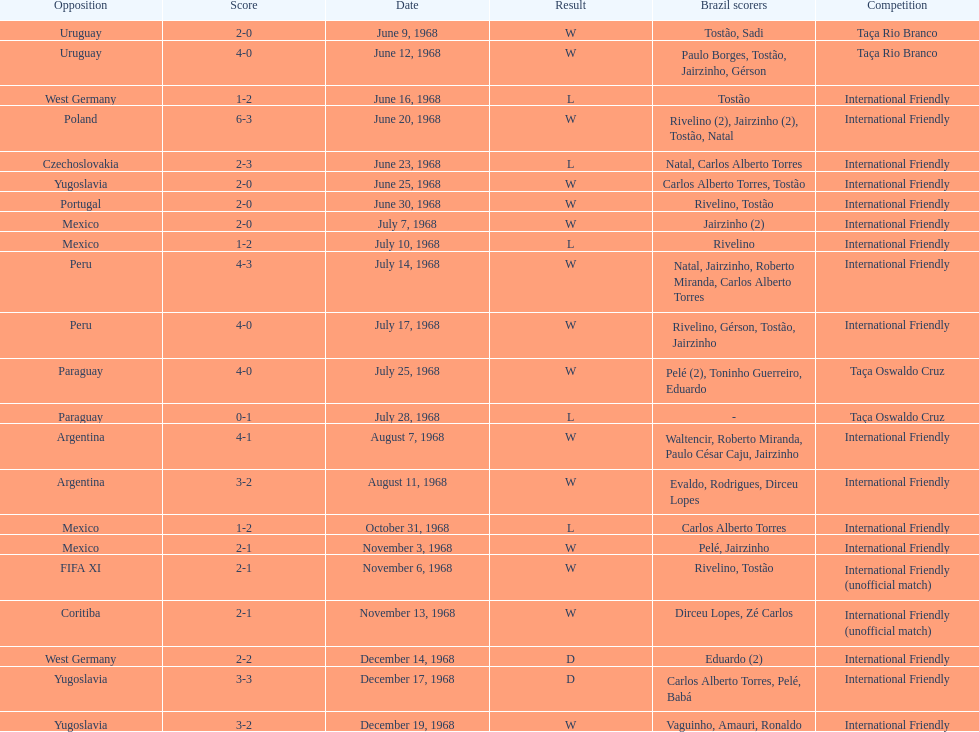Who played brazil previous to the game on june 30th? Yugoslavia. 